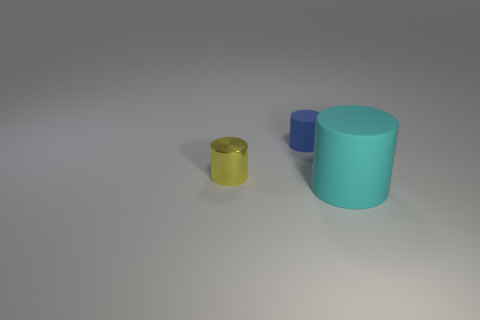Add 1 blue cylinders. How many objects exist? 4 Subtract all cyan rubber cylinders. Subtract all blue cylinders. How many objects are left? 1 Add 3 blue rubber objects. How many blue rubber objects are left? 4 Add 3 purple blocks. How many purple blocks exist? 3 Subtract 0 green spheres. How many objects are left? 3 